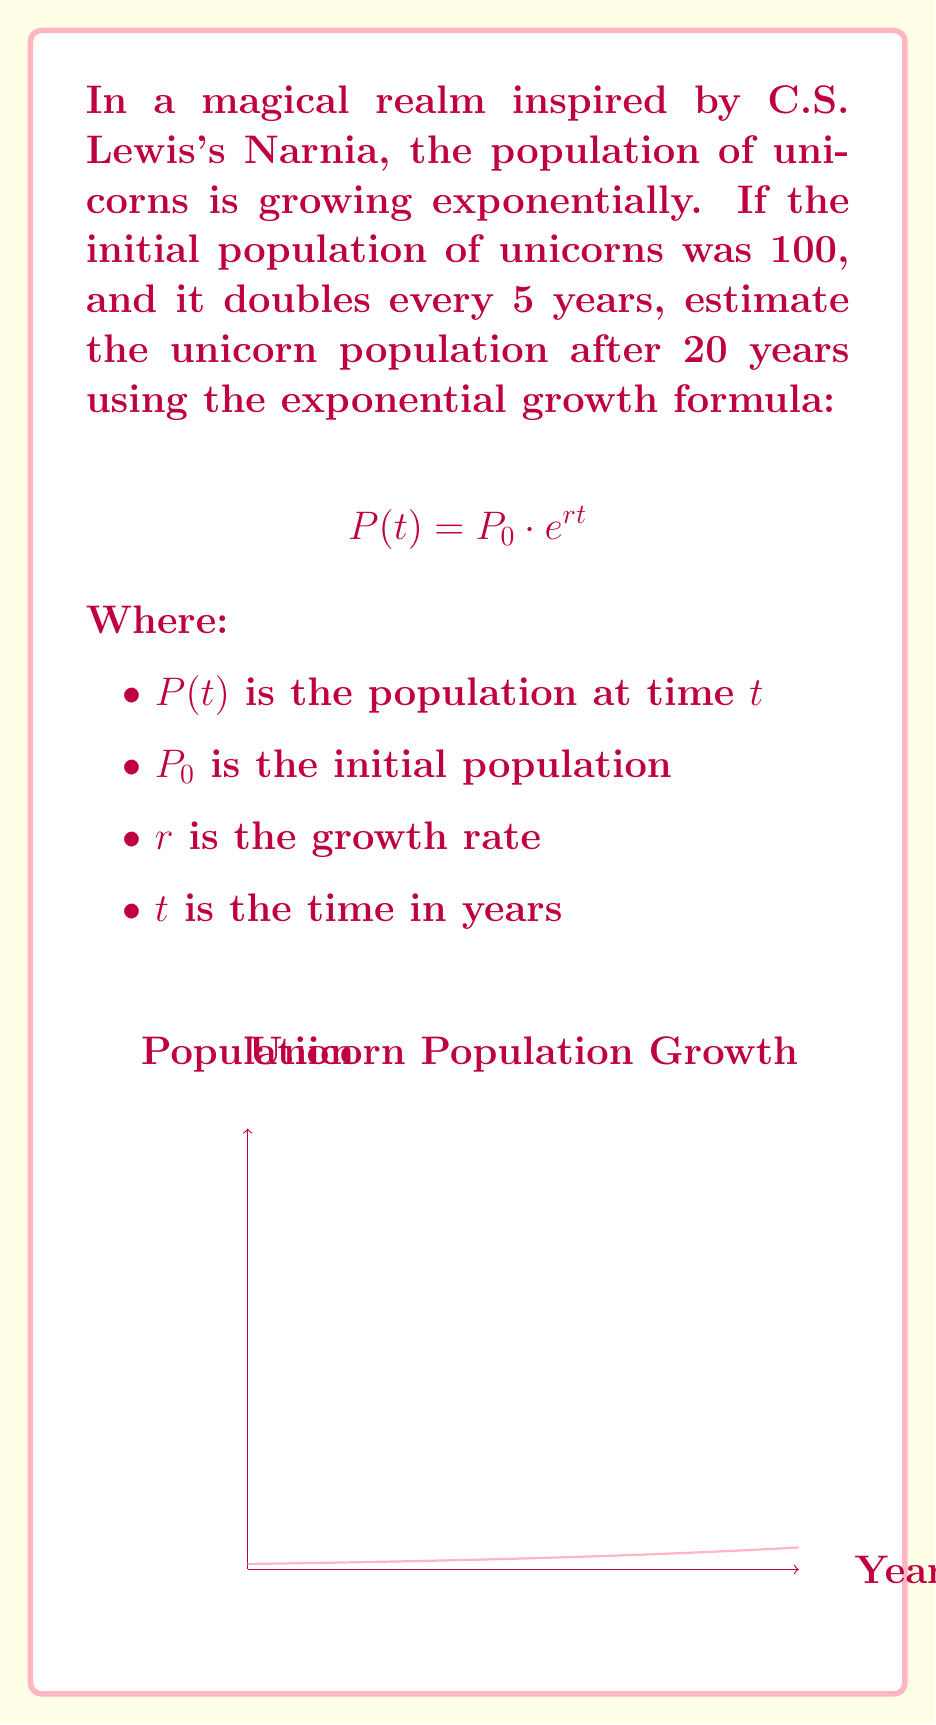Teach me how to tackle this problem. To solve this problem, we'll follow these steps:

1. Identify the given information:
   $P_0 = 100$ (initial population)
   The population doubles every 5 years
   $t = 20$ years

2. Calculate the growth rate $r$:
   Using the doubling time formula: $2 = e^{5r}$
   Taking the natural log of both sides: $\ln(2) = 5r$
   Solving for $r$: $r = \frac{\ln(2)}{5} \approx 0.1386$

3. Apply the exponential growth formula:
   $$P(20) = 100 \cdot e^{0.1386 \cdot 20}$$

4. Calculate the result:
   $$P(20) = 100 \cdot e^{2.772} \approx 1600$$

Therefore, after 20 years, the estimated unicorn population would be approximately 1600.

This growth pattern reflects the biblical concept of "be fruitful and multiply" (Genesis 1:28), albeit applied to mythical creatures in a fantasy setting.
Answer: 1600 unicorns 